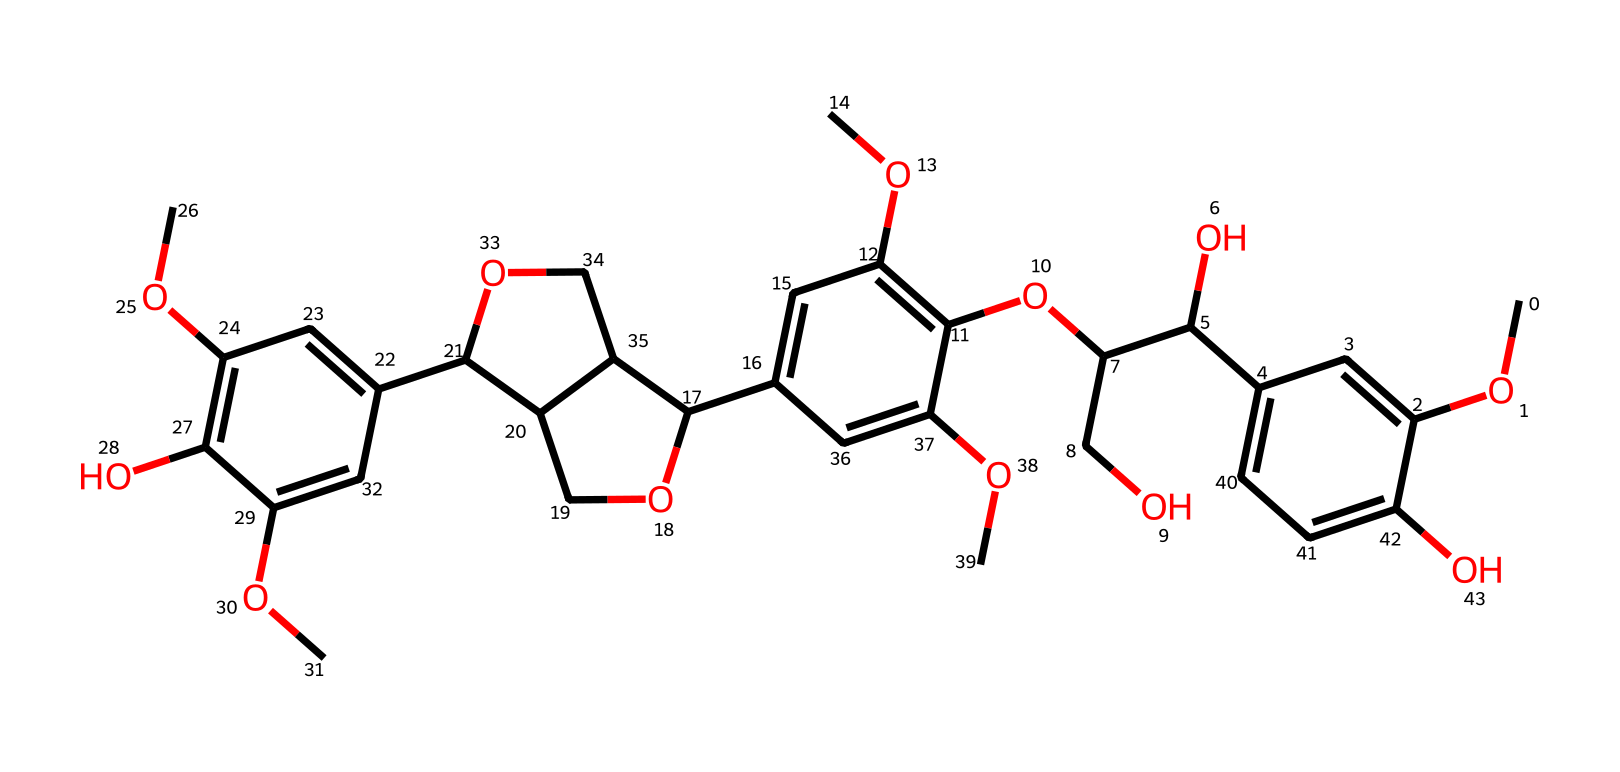What is the molecular weight of the compound represented by this SMILES? To find the molecular weight, we would first break down the SMILES given and identify all the atoms present, counting carbon, hydrogen, oxygen, and any other elements. After recognizing the counts, we multiply the number of each element by its atomic weight and sum them up. The breakdown yields a molecular weight of approximately 442.4 g/mol.
Answer: 442.4 g/mol How many oxygen atoms are present in the chemical structure? In the provided SMILES, we count the occurrences of the letter "O", which represents oxygen atoms. By examining the entire structure, we find there are 10 oxygen atoms present.
Answer: 10 What is the main functional group present in the chemical structure? By analyzing the SMILES, we can identify the presence of hydroxyl groups (-OH), which are characteristic of alcohol functional groups. These groups appear prominently throughout the structure, indicating that alcohol is the main functional group.
Answer: alcohol What determines the solubility of this compound in water? The solubility in water can be determined by the number of hydroxyl groups present in the chemical structure. Each hydroxyl group can form hydrogen bonds with water, increasing the compound's overall solubility. Given that there are several hydroxyl groups in this structure, it suggests a high solubility in water.
Answer: hydrogen bonds Is this compound likely to be hydrophilic or hydrophobic? The presence of multiple hydroxyl groups indicates that this compound can interact favorably with water through hydrogen bonding. This property usually suggests that the compound is hydrophilic. Opposing characteristics like long hydrophobic aliphatic chains are absent in the structure, further supporting this classification.
Answer: hydrophilic 